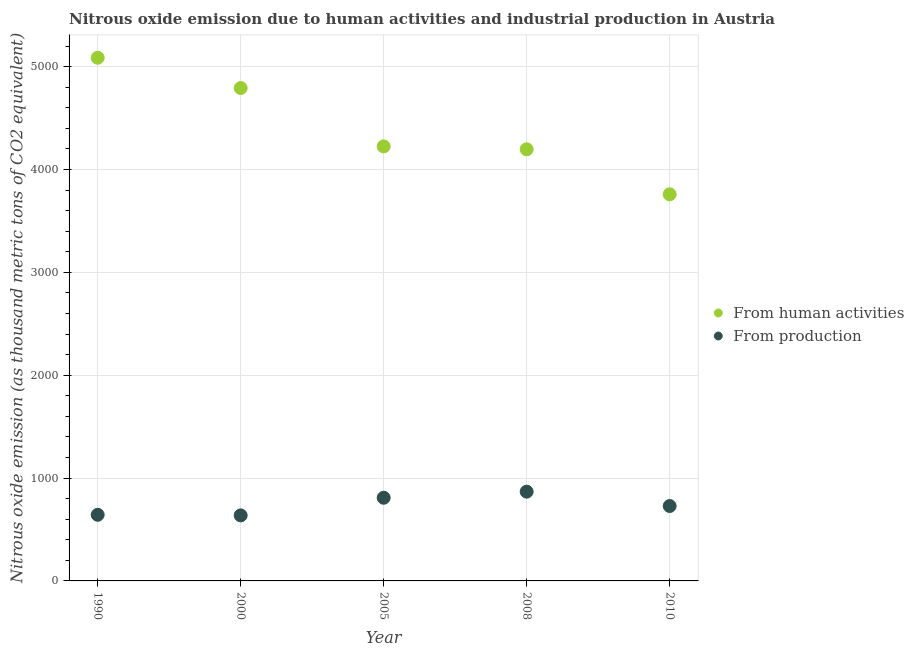Is the number of dotlines equal to the number of legend labels?
Your answer should be compact. Yes. What is the amount of emissions from human activities in 2000?
Keep it short and to the point. 4792. Across all years, what is the maximum amount of emissions from human activities?
Make the answer very short. 5086.3. Across all years, what is the minimum amount of emissions generated from industries?
Your answer should be compact. 637.1. In which year was the amount of emissions from human activities minimum?
Offer a terse response. 2010. What is the total amount of emissions generated from industries in the graph?
Your response must be concise. 3684.8. What is the difference between the amount of emissions from human activities in 2005 and that in 2008?
Offer a very short reply. 28.6. What is the difference between the amount of emissions generated from industries in 2008 and the amount of emissions from human activities in 2005?
Ensure brevity in your answer.  -3356.8. What is the average amount of emissions from human activities per year?
Offer a terse response. 4411.56. In the year 1990, what is the difference between the amount of emissions generated from industries and amount of emissions from human activities?
Ensure brevity in your answer.  -4443.4. In how many years, is the amount of emissions from human activities greater than 4800 thousand metric tons?
Your answer should be compact. 1. What is the ratio of the amount of emissions from human activities in 2008 to that in 2010?
Offer a terse response. 1.12. Is the amount of emissions from human activities in 2000 less than that in 2005?
Your response must be concise. No. What is the difference between the highest and the second highest amount of emissions generated from industries?
Offer a very short reply. 59.3. What is the difference between the highest and the lowest amount of emissions generated from industries?
Offer a very short reply. 230.8. In how many years, is the amount of emissions from human activities greater than the average amount of emissions from human activities taken over all years?
Your answer should be very brief. 2. Is the amount of emissions from human activities strictly less than the amount of emissions generated from industries over the years?
Provide a succinct answer. No. What is the difference between two consecutive major ticks on the Y-axis?
Your response must be concise. 1000. Are the values on the major ticks of Y-axis written in scientific E-notation?
Provide a succinct answer. No. Does the graph contain grids?
Offer a very short reply. Yes. Where does the legend appear in the graph?
Your answer should be very brief. Center right. How are the legend labels stacked?
Offer a terse response. Vertical. What is the title of the graph?
Keep it short and to the point. Nitrous oxide emission due to human activities and industrial production in Austria. Does "2012 US$" appear as one of the legend labels in the graph?
Provide a succinct answer. No. What is the label or title of the X-axis?
Provide a succinct answer. Year. What is the label or title of the Y-axis?
Your answer should be very brief. Nitrous oxide emission (as thousand metric tons of CO2 equivalent). What is the Nitrous oxide emission (as thousand metric tons of CO2 equivalent) of From human activities in 1990?
Offer a terse response. 5086.3. What is the Nitrous oxide emission (as thousand metric tons of CO2 equivalent) of From production in 1990?
Keep it short and to the point. 642.9. What is the Nitrous oxide emission (as thousand metric tons of CO2 equivalent) in From human activities in 2000?
Give a very brief answer. 4792. What is the Nitrous oxide emission (as thousand metric tons of CO2 equivalent) in From production in 2000?
Make the answer very short. 637.1. What is the Nitrous oxide emission (as thousand metric tons of CO2 equivalent) in From human activities in 2005?
Offer a very short reply. 4224.7. What is the Nitrous oxide emission (as thousand metric tons of CO2 equivalent) of From production in 2005?
Your response must be concise. 808.6. What is the Nitrous oxide emission (as thousand metric tons of CO2 equivalent) of From human activities in 2008?
Keep it short and to the point. 4196.1. What is the Nitrous oxide emission (as thousand metric tons of CO2 equivalent) of From production in 2008?
Your answer should be compact. 867.9. What is the Nitrous oxide emission (as thousand metric tons of CO2 equivalent) in From human activities in 2010?
Provide a short and direct response. 3758.7. What is the Nitrous oxide emission (as thousand metric tons of CO2 equivalent) in From production in 2010?
Ensure brevity in your answer.  728.3. Across all years, what is the maximum Nitrous oxide emission (as thousand metric tons of CO2 equivalent) of From human activities?
Your answer should be compact. 5086.3. Across all years, what is the maximum Nitrous oxide emission (as thousand metric tons of CO2 equivalent) in From production?
Provide a succinct answer. 867.9. Across all years, what is the minimum Nitrous oxide emission (as thousand metric tons of CO2 equivalent) of From human activities?
Give a very brief answer. 3758.7. Across all years, what is the minimum Nitrous oxide emission (as thousand metric tons of CO2 equivalent) in From production?
Provide a succinct answer. 637.1. What is the total Nitrous oxide emission (as thousand metric tons of CO2 equivalent) of From human activities in the graph?
Give a very brief answer. 2.21e+04. What is the total Nitrous oxide emission (as thousand metric tons of CO2 equivalent) of From production in the graph?
Offer a terse response. 3684.8. What is the difference between the Nitrous oxide emission (as thousand metric tons of CO2 equivalent) of From human activities in 1990 and that in 2000?
Your answer should be compact. 294.3. What is the difference between the Nitrous oxide emission (as thousand metric tons of CO2 equivalent) of From human activities in 1990 and that in 2005?
Give a very brief answer. 861.6. What is the difference between the Nitrous oxide emission (as thousand metric tons of CO2 equivalent) of From production in 1990 and that in 2005?
Ensure brevity in your answer.  -165.7. What is the difference between the Nitrous oxide emission (as thousand metric tons of CO2 equivalent) of From human activities in 1990 and that in 2008?
Offer a terse response. 890.2. What is the difference between the Nitrous oxide emission (as thousand metric tons of CO2 equivalent) in From production in 1990 and that in 2008?
Provide a succinct answer. -225. What is the difference between the Nitrous oxide emission (as thousand metric tons of CO2 equivalent) in From human activities in 1990 and that in 2010?
Your answer should be compact. 1327.6. What is the difference between the Nitrous oxide emission (as thousand metric tons of CO2 equivalent) in From production in 1990 and that in 2010?
Your response must be concise. -85.4. What is the difference between the Nitrous oxide emission (as thousand metric tons of CO2 equivalent) of From human activities in 2000 and that in 2005?
Your answer should be very brief. 567.3. What is the difference between the Nitrous oxide emission (as thousand metric tons of CO2 equivalent) in From production in 2000 and that in 2005?
Ensure brevity in your answer.  -171.5. What is the difference between the Nitrous oxide emission (as thousand metric tons of CO2 equivalent) of From human activities in 2000 and that in 2008?
Your answer should be compact. 595.9. What is the difference between the Nitrous oxide emission (as thousand metric tons of CO2 equivalent) of From production in 2000 and that in 2008?
Provide a succinct answer. -230.8. What is the difference between the Nitrous oxide emission (as thousand metric tons of CO2 equivalent) of From human activities in 2000 and that in 2010?
Provide a succinct answer. 1033.3. What is the difference between the Nitrous oxide emission (as thousand metric tons of CO2 equivalent) of From production in 2000 and that in 2010?
Make the answer very short. -91.2. What is the difference between the Nitrous oxide emission (as thousand metric tons of CO2 equivalent) in From human activities in 2005 and that in 2008?
Your response must be concise. 28.6. What is the difference between the Nitrous oxide emission (as thousand metric tons of CO2 equivalent) of From production in 2005 and that in 2008?
Ensure brevity in your answer.  -59.3. What is the difference between the Nitrous oxide emission (as thousand metric tons of CO2 equivalent) in From human activities in 2005 and that in 2010?
Keep it short and to the point. 466. What is the difference between the Nitrous oxide emission (as thousand metric tons of CO2 equivalent) in From production in 2005 and that in 2010?
Keep it short and to the point. 80.3. What is the difference between the Nitrous oxide emission (as thousand metric tons of CO2 equivalent) of From human activities in 2008 and that in 2010?
Your response must be concise. 437.4. What is the difference between the Nitrous oxide emission (as thousand metric tons of CO2 equivalent) of From production in 2008 and that in 2010?
Offer a terse response. 139.6. What is the difference between the Nitrous oxide emission (as thousand metric tons of CO2 equivalent) of From human activities in 1990 and the Nitrous oxide emission (as thousand metric tons of CO2 equivalent) of From production in 2000?
Provide a succinct answer. 4449.2. What is the difference between the Nitrous oxide emission (as thousand metric tons of CO2 equivalent) of From human activities in 1990 and the Nitrous oxide emission (as thousand metric tons of CO2 equivalent) of From production in 2005?
Make the answer very short. 4277.7. What is the difference between the Nitrous oxide emission (as thousand metric tons of CO2 equivalent) in From human activities in 1990 and the Nitrous oxide emission (as thousand metric tons of CO2 equivalent) in From production in 2008?
Ensure brevity in your answer.  4218.4. What is the difference between the Nitrous oxide emission (as thousand metric tons of CO2 equivalent) in From human activities in 1990 and the Nitrous oxide emission (as thousand metric tons of CO2 equivalent) in From production in 2010?
Keep it short and to the point. 4358. What is the difference between the Nitrous oxide emission (as thousand metric tons of CO2 equivalent) of From human activities in 2000 and the Nitrous oxide emission (as thousand metric tons of CO2 equivalent) of From production in 2005?
Provide a short and direct response. 3983.4. What is the difference between the Nitrous oxide emission (as thousand metric tons of CO2 equivalent) of From human activities in 2000 and the Nitrous oxide emission (as thousand metric tons of CO2 equivalent) of From production in 2008?
Ensure brevity in your answer.  3924.1. What is the difference between the Nitrous oxide emission (as thousand metric tons of CO2 equivalent) in From human activities in 2000 and the Nitrous oxide emission (as thousand metric tons of CO2 equivalent) in From production in 2010?
Offer a very short reply. 4063.7. What is the difference between the Nitrous oxide emission (as thousand metric tons of CO2 equivalent) of From human activities in 2005 and the Nitrous oxide emission (as thousand metric tons of CO2 equivalent) of From production in 2008?
Offer a terse response. 3356.8. What is the difference between the Nitrous oxide emission (as thousand metric tons of CO2 equivalent) in From human activities in 2005 and the Nitrous oxide emission (as thousand metric tons of CO2 equivalent) in From production in 2010?
Make the answer very short. 3496.4. What is the difference between the Nitrous oxide emission (as thousand metric tons of CO2 equivalent) in From human activities in 2008 and the Nitrous oxide emission (as thousand metric tons of CO2 equivalent) in From production in 2010?
Offer a very short reply. 3467.8. What is the average Nitrous oxide emission (as thousand metric tons of CO2 equivalent) of From human activities per year?
Your answer should be very brief. 4411.56. What is the average Nitrous oxide emission (as thousand metric tons of CO2 equivalent) in From production per year?
Provide a succinct answer. 736.96. In the year 1990, what is the difference between the Nitrous oxide emission (as thousand metric tons of CO2 equivalent) in From human activities and Nitrous oxide emission (as thousand metric tons of CO2 equivalent) in From production?
Keep it short and to the point. 4443.4. In the year 2000, what is the difference between the Nitrous oxide emission (as thousand metric tons of CO2 equivalent) in From human activities and Nitrous oxide emission (as thousand metric tons of CO2 equivalent) in From production?
Give a very brief answer. 4154.9. In the year 2005, what is the difference between the Nitrous oxide emission (as thousand metric tons of CO2 equivalent) of From human activities and Nitrous oxide emission (as thousand metric tons of CO2 equivalent) of From production?
Make the answer very short. 3416.1. In the year 2008, what is the difference between the Nitrous oxide emission (as thousand metric tons of CO2 equivalent) in From human activities and Nitrous oxide emission (as thousand metric tons of CO2 equivalent) in From production?
Offer a terse response. 3328.2. In the year 2010, what is the difference between the Nitrous oxide emission (as thousand metric tons of CO2 equivalent) of From human activities and Nitrous oxide emission (as thousand metric tons of CO2 equivalent) of From production?
Your answer should be very brief. 3030.4. What is the ratio of the Nitrous oxide emission (as thousand metric tons of CO2 equivalent) in From human activities in 1990 to that in 2000?
Give a very brief answer. 1.06. What is the ratio of the Nitrous oxide emission (as thousand metric tons of CO2 equivalent) in From production in 1990 to that in 2000?
Provide a short and direct response. 1.01. What is the ratio of the Nitrous oxide emission (as thousand metric tons of CO2 equivalent) in From human activities in 1990 to that in 2005?
Ensure brevity in your answer.  1.2. What is the ratio of the Nitrous oxide emission (as thousand metric tons of CO2 equivalent) in From production in 1990 to that in 2005?
Your answer should be very brief. 0.8. What is the ratio of the Nitrous oxide emission (as thousand metric tons of CO2 equivalent) in From human activities in 1990 to that in 2008?
Provide a short and direct response. 1.21. What is the ratio of the Nitrous oxide emission (as thousand metric tons of CO2 equivalent) in From production in 1990 to that in 2008?
Ensure brevity in your answer.  0.74. What is the ratio of the Nitrous oxide emission (as thousand metric tons of CO2 equivalent) in From human activities in 1990 to that in 2010?
Make the answer very short. 1.35. What is the ratio of the Nitrous oxide emission (as thousand metric tons of CO2 equivalent) of From production in 1990 to that in 2010?
Provide a short and direct response. 0.88. What is the ratio of the Nitrous oxide emission (as thousand metric tons of CO2 equivalent) of From human activities in 2000 to that in 2005?
Provide a short and direct response. 1.13. What is the ratio of the Nitrous oxide emission (as thousand metric tons of CO2 equivalent) of From production in 2000 to that in 2005?
Provide a succinct answer. 0.79. What is the ratio of the Nitrous oxide emission (as thousand metric tons of CO2 equivalent) of From human activities in 2000 to that in 2008?
Your response must be concise. 1.14. What is the ratio of the Nitrous oxide emission (as thousand metric tons of CO2 equivalent) in From production in 2000 to that in 2008?
Your answer should be compact. 0.73. What is the ratio of the Nitrous oxide emission (as thousand metric tons of CO2 equivalent) of From human activities in 2000 to that in 2010?
Provide a short and direct response. 1.27. What is the ratio of the Nitrous oxide emission (as thousand metric tons of CO2 equivalent) in From production in 2000 to that in 2010?
Provide a succinct answer. 0.87. What is the ratio of the Nitrous oxide emission (as thousand metric tons of CO2 equivalent) of From human activities in 2005 to that in 2008?
Provide a succinct answer. 1.01. What is the ratio of the Nitrous oxide emission (as thousand metric tons of CO2 equivalent) of From production in 2005 to that in 2008?
Your answer should be very brief. 0.93. What is the ratio of the Nitrous oxide emission (as thousand metric tons of CO2 equivalent) in From human activities in 2005 to that in 2010?
Offer a terse response. 1.12. What is the ratio of the Nitrous oxide emission (as thousand metric tons of CO2 equivalent) in From production in 2005 to that in 2010?
Give a very brief answer. 1.11. What is the ratio of the Nitrous oxide emission (as thousand metric tons of CO2 equivalent) in From human activities in 2008 to that in 2010?
Your answer should be very brief. 1.12. What is the ratio of the Nitrous oxide emission (as thousand metric tons of CO2 equivalent) in From production in 2008 to that in 2010?
Give a very brief answer. 1.19. What is the difference between the highest and the second highest Nitrous oxide emission (as thousand metric tons of CO2 equivalent) in From human activities?
Your response must be concise. 294.3. What is the difference between the highest and the second highest Nitrous oxide emission (as thousand metric tons of CO2 equivalent) of From production?
Your response must be concise. 59.3. What is the difference between the highest and the lowest Nitrous oxide emission (as thousand metric tons of CO2 equivalent) in From human activities?
Make the answer very short. 1327.6. What is the difference between the highest and the lowest Nitrous oxide emission (as thousand metric tons of CO2 equivalent) of From production?
Provide a short and direct response. 230.8. 